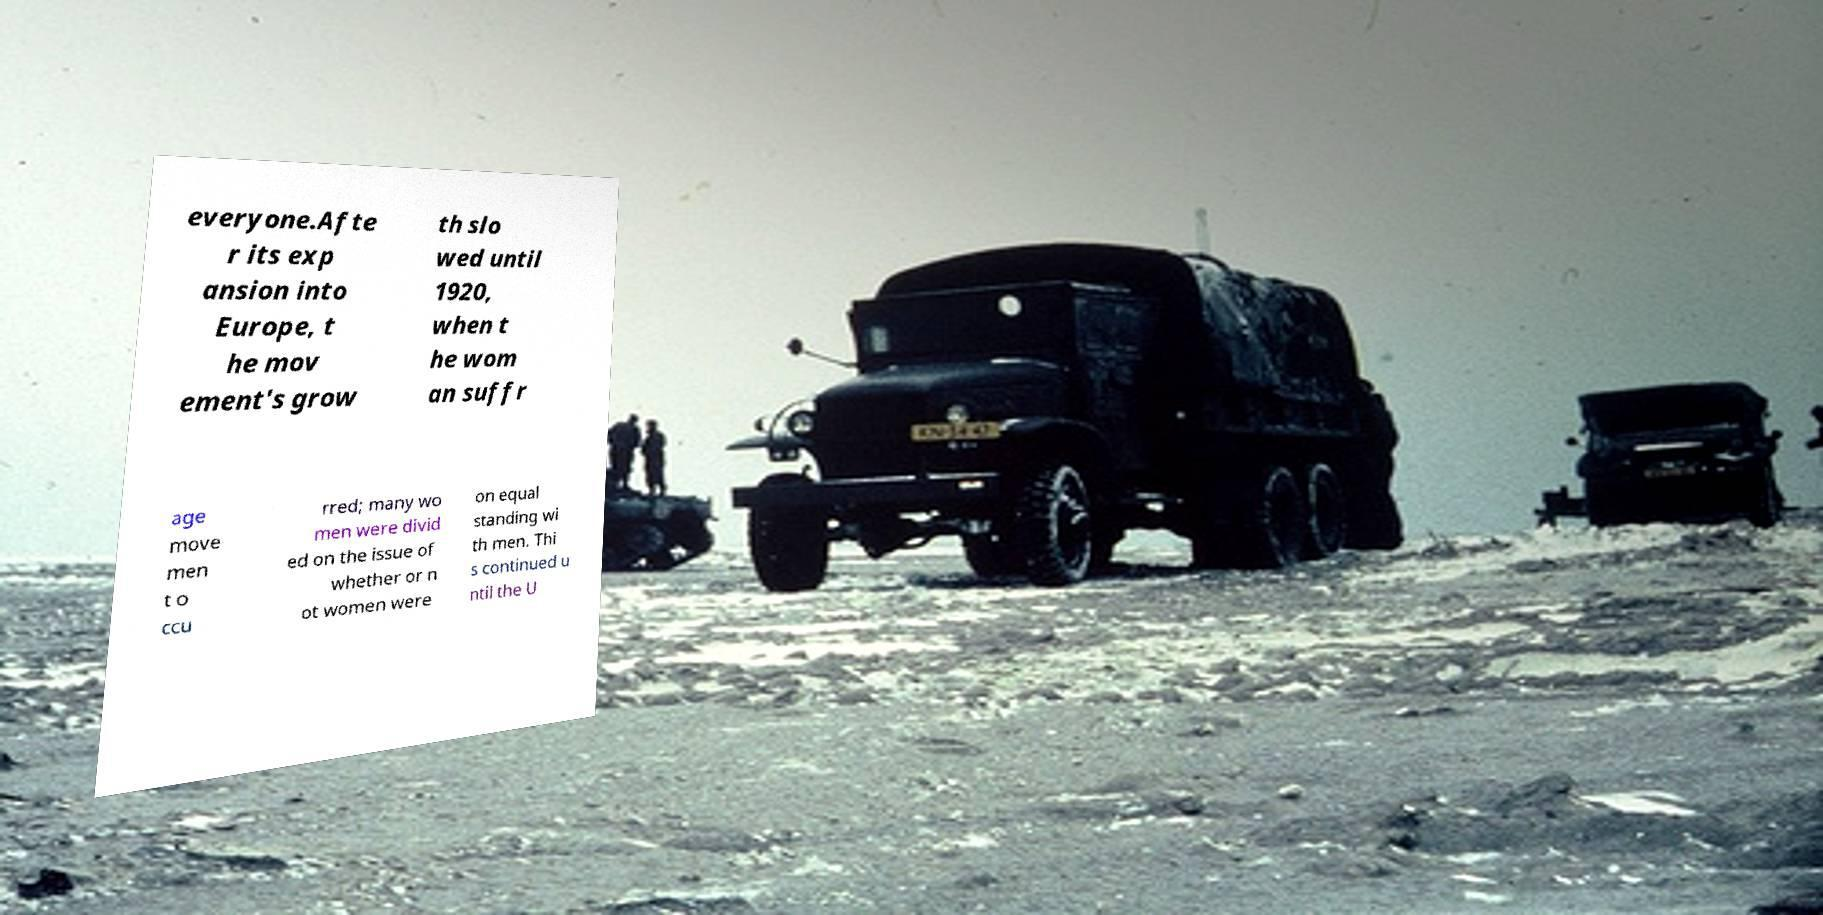Please identify and transcribe the text found in this image. everyone.Afte r its exp ansion into Europe, t he mov ement's grow th slo wed until 1920, when t he wom an suffr age move men t o ccu rred; many wo men were divid ed on the issue of whether or n ot women were on equal standing wi th men. Thi s continued u ntil the U 